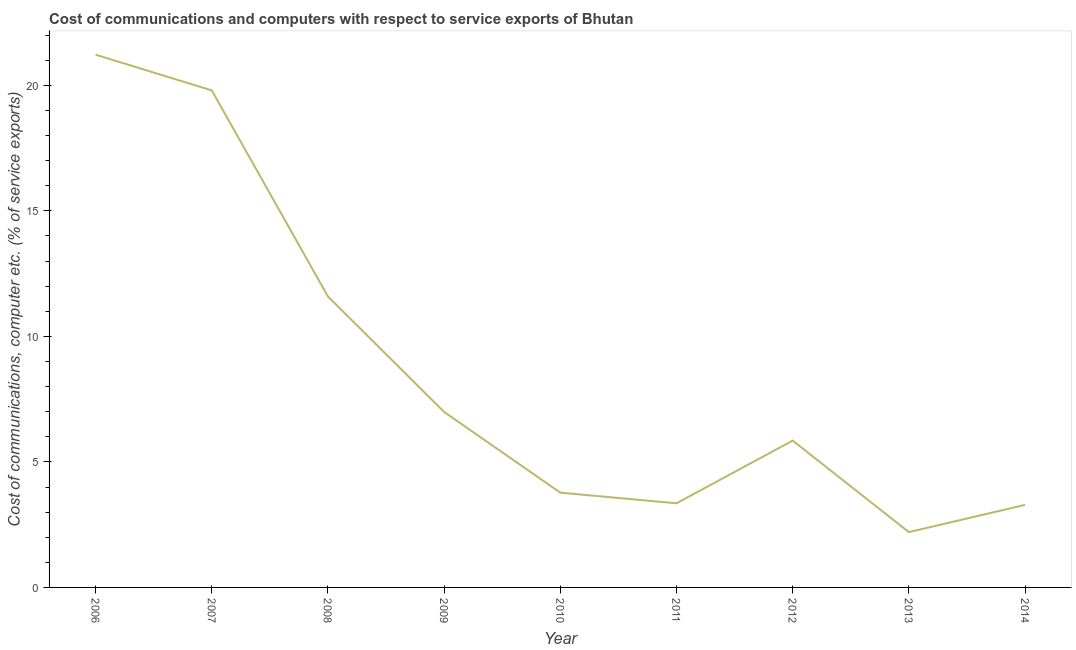What is the cost of communications and computer in 2008?
Your response must be concise. 11.59. Across all years, what is the maximum cost of communications and computer?
Give a very brief answer. 21.22. Across all years, what is the minimum cost of communications and computer?
Your answer should be compact. 2.2. In which year was the cost of communications and computer minimum?
Offer a very short reply. 2013. What is the sum of the cost of communications and computer?
Make the answer very short. 78.07. What is the difference between the cost of communications and computer in 2008 and 2011?
Provide a short and direct response. 8.24. What is the average cost of communications and computer per year?
Your answer should be compact. 8.67. What is the median cost of communications and computer?
Keep it short and to the point. 5.85. In how many years, is the cost of communications and computer greater than 12 %?
Provide a succinct answer. 2. Do a majority of the years between 2010 and 2007 (inclusive) have cost of communications and computer greater than 3 %?
Offer a terse response. Yes. What is the ratio of the cost of communications and computer in 2009 to that in 2014?
Your answer should be compact. 2.13. Is the cost of communications and computer in 2006 less than that in 2008?
Give a very brief answer. No. Is the difference between the cost of communications and computer in 2006 and 2007 greater than the difference between any two years?
Offer a terse response. No. What is the difference between the highest and the second highest cost of communications and computer?
Offer a terse response. 1.42. What is the difference between the highest and the lowest cost of communications and computer?
Make the answer very short. 19.02. Does the cost of communications and computer monotonically increase over the years?
Offer a terse response. No. How many years are there in the graph?
Your answer should be very brief. 9. What is the title of the graph?
Offer a terse response. Cost of communications and computers with respect to service exports of Bhutan. What is the label or title of the Y-axis?
Your response must be concise. Cost of communications, computer etc. (% of service exports). What is the Cost of communications, computer etc. (% of service exports) in 2006?
Offer a terse response. 21.22. What is the Cost of communications, computer etc. (% of service exports) of 2007?
Keep it short and to the point. 19.8. What is the Cost of communications, computer etc. (% of service exports) of 2008?
Your response must be concise. 11.59. What is the Cost of communications, computer etc. (% of service exports) of 2009?
Provide a succinct answer. 6.99. What is the Cost of communications, computer etc. (% of service exports) of 2010?
Ensure brevity in your answer.  3.78. What is the Cost of communications, computer etc. (% of service exports) of 2011?
Offer a very short reply. 3.35. What is the Cost of communications, computer etc. (% of service exports) of 2012?
Your answer should be compact. 5.85. What is the Cost of communications, computer etc. (% of service exports) in 2013?
Give a very brief answer. 2.2. What is the Cost of communications, computer etc. (% of service exports) of 2014?
Ensure brevity in your answer.  3.29. What is the difference between the Cost of communications, computer etc. (% of service exports) in 2006 and 2007?
Your answer should be very brief. 1.42. What is the difference between the Cost of communications, computer etc. (% of service exports) in 2006 and 2008?
Ensure brevity in your answer.  9.63. What is the difference between the Cost of communications, computer etc. (% of service exports) in 2006 and 2009?
Make the answer very short. 14.23. What is the difference between the Cost of communications, computer etc. (% of service exports) in 2006 and 2010?
Offer a very short reply. 17.45. What is the difference between the Cost of communications, computer etc. (% of service exports) in 2006 and 2011?
Ensure brevity in your answer.  17.87. What is the difference between the Cost of communications, computer etc. (% of service exports) in 2006 and 2012?
Keep it short and to the point. 15.37. What is the difference between the Cost of communications, computer etc. (% of service exports) in 2006 and 2013?
Ensure brevity in your answer.  19.02. What is the difference between the Cost of communications, computer etc. (% of service exports) in 2006 and 2014?
Your answer should be very brief. 17.93. What is the difference between the Cost of communications, computer etc. (% of service exports) in 2007 and 2008?
Provide a short and direct response. 8.21. What is the difference between the Cost of communications, computer etc. (% of service exports) in 2007 and 2009?
Provide a short and direct response. 12.81. What is the difference between the Cost of communications, computer etc. (% of service exports) in 2007 and 2010?
Provide a succinct answer. 16.02. What is the difference between the Cost of communications, computer etc. (% of service exports) in 2007 and 2011?
Make the answer very short. 16.45. What is the difference between the Cost of communications, computer etc. (% of service exports) in 2007 and 2012?
Your response must be concise. 13.95. What is the difference between the Cost of communications, computer etc. (% of service exports) in 2007 and 2013?
Provide a succinct answer. 17.6. What is the difference between the Cost of communications, computer etc. (% of service exports) in 2007 and 2014?
Your response must be concise. 16.51. What is the difference between the Cost of communications, computer etc. (% of service exports) in 2008 and 2009?
Provide a short and direct response. 4.6. What is the difference between the Cost of communications, computer etc. (% of service exports) in 2008 and 2010?
Your answer should be compact. 7.81. What is the difference between the Cost of communications, computer etc. (% of service exports) in 2008 and 2011?
Your answer should be very brief. 8.24. What is the difference between the Cost of communications, computer etc. (% of service exports) in 2008 and 2012?
Provide a succinct answer. 5.74. What is the difference between the Cost of communications, computer etc. (% of service exports) in 2008 and 2013?
Your response must be concise. 9.38. What is the difference between the Cost of communications, computer etc. (% of service exports) in 2008 and 2014?
Give a very brief answer. 8.3. What is the difference between the Cost of communications, computer etc. (% of service exports) in 2009 and 2010?
Give a very brief answer. 3.21. What is the difference between the Cost of communications, computer etc. (% of service exports) in 2009 and 2011?
Ensure brevity in your answer.  3.64. What is the difference between the Cost of communications, computer etc. (% of service exports) in 2009 and 2012?
Offer a very short reply. 1.14. What is the difference between the Cost of communications, computer etc. (% of service exports) in 2009 and 2013?
Keep it short and to the point. 4.79. What is the difference between the Cost of communications, computer etc. (% of service exports) in 2009 and 2014?
Ensure brevity in your answer.  3.7. What is the difference between the Cost of communications, computer etc. (% of service exports) in 2010 and 2011?
Provide a short and direct response. 0.42. What is the difference between the Cost of communications, computer etc. (% of service exports) in 2010 and 2012?
Make the answer very short. -2.07. What is the difference between the Cost of communications, computer etc. (% of service exports) in 2010 and 2013?
Give a very brief answer. 1.57. What is the difference between the Cost of communications, computer etc. (% of service exports) in 2010 and 2014?
Offer a terse response. 0.49. What is the difference between the Cost of communications, computer etc. (% of service exports) in 2011 and 2012?
Provide a succinct answer. -2.5. What is the difference between the Cost of communications, computer etc. (% of service exports) in 2011 and 2013?
Your response must be concise. 1.15. What is the difference between the Cost of communications, computer etc. (% of service exports) in 2011 and 2014?
Ensure brevity in your answer.  0.06. What is the difference between the Cost of communications, computer etc. (% of service exports) in 2012 and 2013?
Give a very brief answer. 3.65. What is the difference between the Cost of communications, computer etc. (% of service exports) in 2012 and 2014?
Offer a very short reply. 2.56. What is the difference between the Cost of communications, computer etc. (% of service exports) in 2013 and 2014?
Your answer should be very brief. -1.08. What is the ratio of the Cost of communications, computer etc. (% of service exports) in 2006 to that in 2007?
Provide a short and direct response. 1.07. What is the ratio of the Cost of communications, computer etc. (% of service exports) in 2006 to that in 2008?
Make the answer very short. 1.83. What is the ratio of the Cost of communications, computer etc. (% of service exports) in 2006 to that in 2009?
Keep it short and to the point. 3.04. What is the ratio of the Cost of communications, computer etc. (% of service exports) in 2006 to that in 2010?
Make the answer very short. 5.62. What is the ratio of the Cost of communications, computer etc. (% of service exports) in 2006 to that in 2011?
Offer a very short reply. 6.33. What is the ratio of the Cost of communications, computer etc. (% of service exports) in 2006 to that in 2012?
Offer a terse response. 3.63. What is the ratio of the Cost of communications, computer etc. (% of service exports) in 2006 to that in 2013?
Your answer should be very brief. 9.63. What is the ratio of the Cost of communications, computer etc. (% of service exports) in 2006 to that in 2014?
Keep it short and to the point. 6.46. What is the ratio of the Cost of communications, computer etc. (% of service exports) in 2007 to that in 2008?
Keep it short and to the point. 1.71. What is the ratio of the Cost of communications, computer etc. (% of service exports) in 2007 to that in 2009?
Offer a terse response. 2.83. What is the ratio of the Cost of communications, computer etc. (% of service exports) in 2007 to that in 2010?
Provide a short and direct response. 5.24. What is the ratio of the Cost of communications, computer etc. (% of service exports) in 2007 to that in 2011?
Your answer should be very brief. 5.91. What is the ratio of the Cost of communications, computer etc. (% of service exports) in 2007 to that in 2012?
Provide a succinct answer. 3.38. What is the ratio of the Cost of communications, computer etc. (% of service exports) in 2007 to that in 2013?
Give a very brief answer. 8.98. What is the ratio of the Cost of communications, computer etc. (% of service exports) in 2007 to that in 2014?
Your answer should be very brief. 6.02. What is the ratio of the Cost of communications, computer etc. (% of service exports) in 2008 to that in 2009?
Make the answer very short. 1.66. What is the ratio of the Cost of communications, computer etc. (% of service exports) in 2008 to that in 2010?
Your response must be concise. 3.07. What is the ratio of the Cost of communications, computer etc. (% of service exports) in 2008 to that in 2011?
Your answer should be very brief. 3.46. What is the ratio of the Cost of communications, computer etc. (% of service exports) in 2008 to that in 2012?
Offer a terse response. 1.98. What is the ratio of the Cost of communications, computer etc. (% of service exports) in 2008 to that in 2013?
Your answer should be very brief. 5.26. What is the ratio of the Cost of communications, computer etc. (% of service exports) in 2008 to that in 2014?
Offer a terse response. 3.52. What is the ratio of the Cost of communications, computer etc. (% of service exports) in 2009 to that in 2010?
Keep it short and to the point. 1.85. What is the ratio of the Cost of communications, computer etc. (% of service exports) in 2009 to that in 2011?
Make the answer very short. 2.09. What is the ratio of the Cost of communications, computer etc. (% of service exports) in 2009 to that in 2012?
Keep it short and to the point. 1.2. What is the ratio of the Cost of communications, computer etc. (% of service exports) in 2009 to that in 2013?
Provide a succinct answer. 3.17. What is the ratio of the Cost of communications, computer etc. (% of service exports) in 2009 to that in 2014?
Offer a very short reply. 2.13. What is the ratio of the Cost of communications, computer etc. (% of service exports) in 2010 to that in 2011?
Your answer should be compact. 1.13. What is the ratio of the Cost of communications, computer etc. (% of service exports) in 2010 to that in 2012?
Your answer should be compact. 0.65. What is the ratio of the Cost of communications, computer etc. (% of service exports) in 2010 to that in 2013?
Give a very brief answer. 1.71. What is the ratio of the Cost of communications, computer etc. (% of service exports) in 2010 to that in 2014?
Your answer should be compact. 1.15. What is the ratio of the Cost of communications, computer etc. (% of service exports) in 2011 to that in 2012?
Your response must be concise. 0.57. What is the ratio of the Cost of communications, computer etc. (% of service exports) in 2011 to that in 2013?
Your response must be concise. 1.52. What is the ratio of the Cost of communications, computer etc. (% of service exports) in 2011 to that in 2014?
Offer a very short reply. 1.02. What is the ratio of the Cost of communications, computer etc. (% of service exports) in 2012 to that in 2013?
Your answer should be very brief. 2.65. What is the ratio of the Cost of communications, computer etc. (% of service exports) in 2012 to that in 2014?
Your response must be concise. 1.78. What is the ratio of the Cost of communications, computer etc. (% of service exports) in 2013 to that in 2014?
Give a very brief answer. 0.67. 